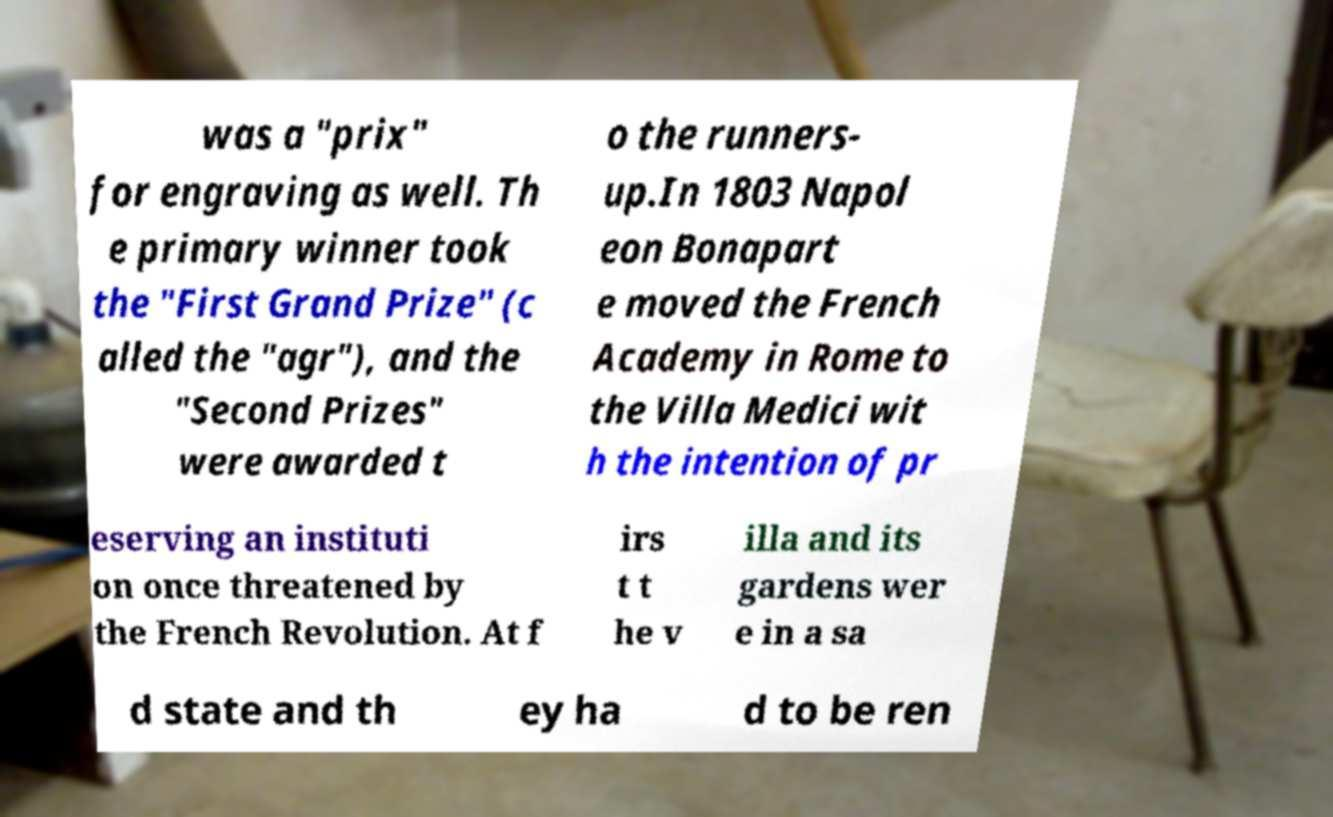Can you read and provide the text displayed in the image?This photo seems to have some interesting text. Can you extract and type it out for me? was a "prix" for engraving as well. Th e primary winner took the "First Grand Prize" (c alled the "agr"), and the "Second Prizes" were awarded t o the runners- up.In 1803 Napol eon Bonapart e moved the French Academy in Rome to the Villa Medici wit h the intention of pr eserving an instituti on once threatened by the French Revolution. At f irs t t he v illa and its gardens wer e in a sa d state and th ey ha d to be ren 